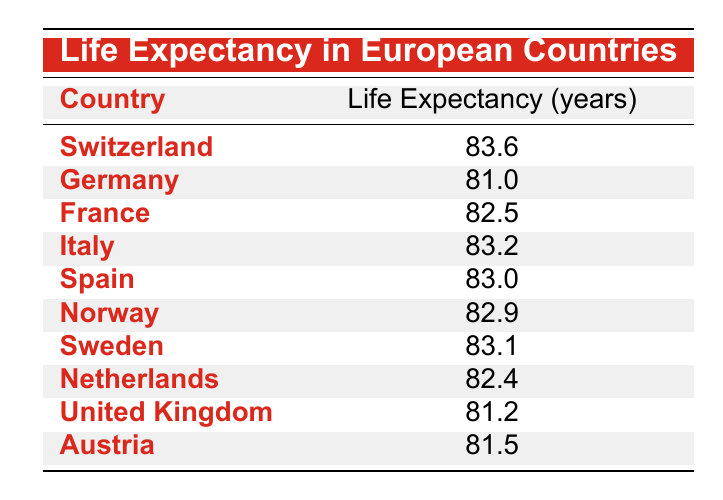What is the life expectancy in Switzerland? The table lists Switzerland with a life expectancy of 83.6 years.
Answer: 83.6 Which country has a life expectancy of 81.5 years? According to the table, Austria has a life expectancy of 81.5 years.
Answer: Austria What is the average life expectancy of Germany and the United Kingdom? The life expectancy for Germany is 81.0 years and for the United Kingdom is 81.2 years. The average is (81.0 + 81.2) / 2 = 81.1 years.
Answer: 81.1 Is Italy's life expectancy greater than that of Sweden? Italy's life expectancy is 83.2 years while Sweden's is 83.1 years. Since 83.2 is greater than 83.1, the statement is true.
Answer: Yes How many countries have a life expectancy of 82 years or more? The countries with a life expectancy of 82 years or more are Switzerland (83.6), Italy (83.2), Spain (83.0), Norway (82.9), Sweden (83.1), and France (82.5). That totals 6 countries.
Answer: 6 What is the difference in life expectancy between France and Germany? France has a life expectancy of 82.5 years and Germany has 81.0 years. The difference is 82.5 - 81.0 = 1.5 years.
Answer: 1.5 Are Norway and the Netherlands the only countries with a life expectancy below 83 years? No, in addition to Norway (82.9) and the Netherlands (82.4), Germany (81.0), the United Kingdom (81.2), and Austria (81.5) also fall below 83 years.
Answer: No Which country has the highest life expectancy in the table? The highest life expectancy in the table is 83.6 years, which belongs to Switzerland.
Answer: Switzerland 